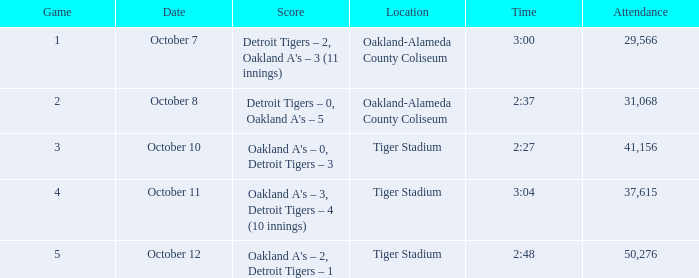What is the number of people in attendance when the time is 3:00? 29566.0. 